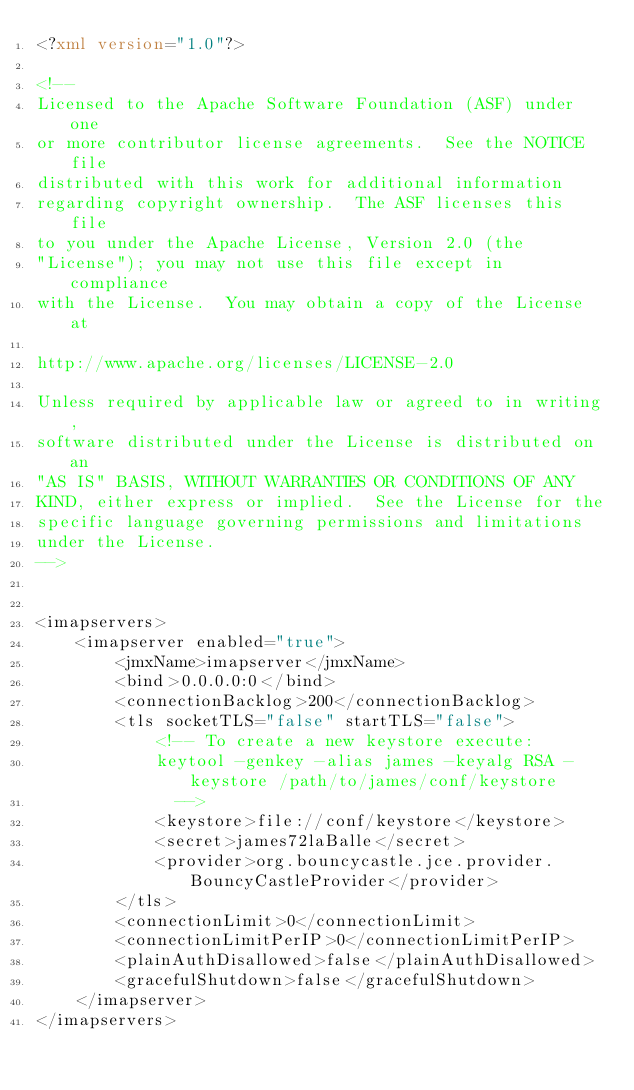Convert code to text. <code><loc_0><loc_0><loc_500><loc_500><_XML_><?xml version="1.0"?>

<!--
Licensed to the Apache Software Foundation (ASF) under one
or more contributor license agreements.  See the NOTICE file
distributed with this work for additional information
regarding copyright ownership.  The ASF licenses this file
to you under the Apache License, Version 2.0 (the
"License"); you may not use this file except in compliance
with the License.  You may obtain a copy of the License at

http://www.apache.org/licenses/LICENSE-2.0

Unless required by applicable law or agreed to in writing,
software distributed under the License is distributed on an
"AS IS" BASIS, WITHOUT WARRANTIES OR CONDITIONS OF ANY
KIND, either express or implied.  See the License for the
specific language governing permissions and limitations
under the License.
-->


<imapservers>
    <imapserver enabled="true">
        <jmxName>imapserver</jmxName>
        <bind>0.0.0.0:0</bind>
        <connectionBacklog>200</connectionBacklog>
        <tls socketTLS="false" startTLS="false">
            <!-- To create a new keystore execute:
            keytool -genkey -alias james -keyalg RSA -keystore /path/to/james/conf/keystore
              -->
            <keystore>file://conf/keystore</keystore>
            <secret>james72laBalle</secret>
            <provider>org.bouncycastle.jce.provider.BouncyCastleProvider</provider>
        </tls>
        <connectionLimit>0</connectionLimit>
        <connectionLimitPerIP>0</connectionLimitPerIP>
        <plainAuthDisallowed>false</plainAuthDisallowed>
        <gracefulShutdown>false</gracefulShutdown>
    </imapserver>
</imapservers>
</code> 